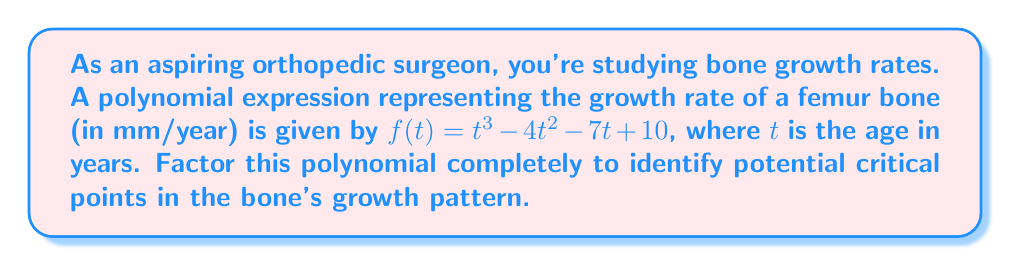Show me your answer to this math problem. Let's factor this polynomial step by step:

1) First, check if there are any common factors. In this case, there are none.

2) Next, try to identify if this is a perfect cube or if it has a factor of the form $(t-a)$. We can use the rational root theorem to find potential factors. The potential rational roots are the factors of the constant term: $±1, ±2, ±5, ±10$.

3) Testing these values, we find that $f(1) = 0$. So $(t-1)$ is a factor.

4) Divide $f(t)$ by $(t-1)$ using polynomial long division:

   $$t^3 - 4t^2 - 7t + 10 = (t-1)(t^2 - 3t - 10)$$

5) Now we need to factor the quadratic term $t^2 - 3t - 10$. We can do this by finding two numbers that multiply to give $-10$ and add to give $-3$. These numbers are $-5$ and $2$.

6) Therefore, $t^2 - 3t - 10 = (t-5)(t+2)$

7) Combining all factors, we get:

   $$f(t) = (t-1)(t-5)(t+2)$$

This factored form reveals that the growth rate is zero when $t = 1, 5,$ and $-2$ (although negative age is not physically meaningful in this context).
Answer: $(t-1)(t-5)(t+2)$ 